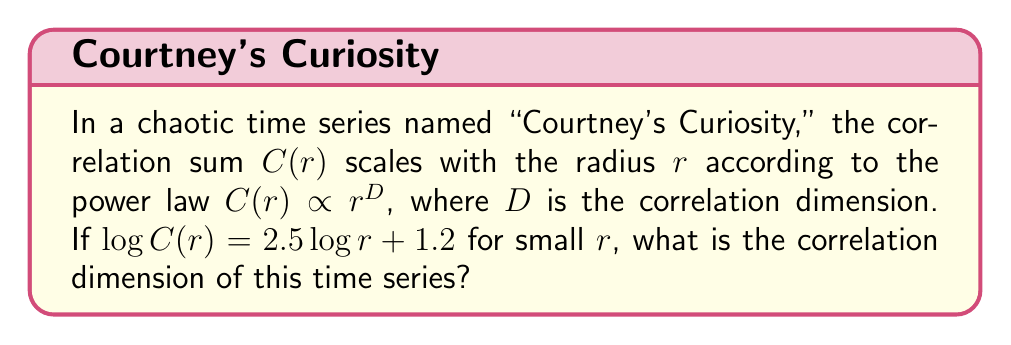Help me with this question. To find the correlation dimension, we need to follow these steps:

1) The general form of the correlation sum scaling is:

   $C(r) \propto r^D$

2) Taking the logarithm of both sides:

   $\log C(r) \propto D \log r$

3) This can be written in the form of a linear equation:

   $\log C(r) = D \log r + b$

   where $b$ is some constant.

4) Comparing this to the given equation:

   $\log C(r) = 2.5 \log r + 1.2$

5) We can see that the coefficient of $\log r$ is the correlation dimension $D$.

Therefore, the correlation dimension $D = 2.5$.
Answer: $2.5$ 